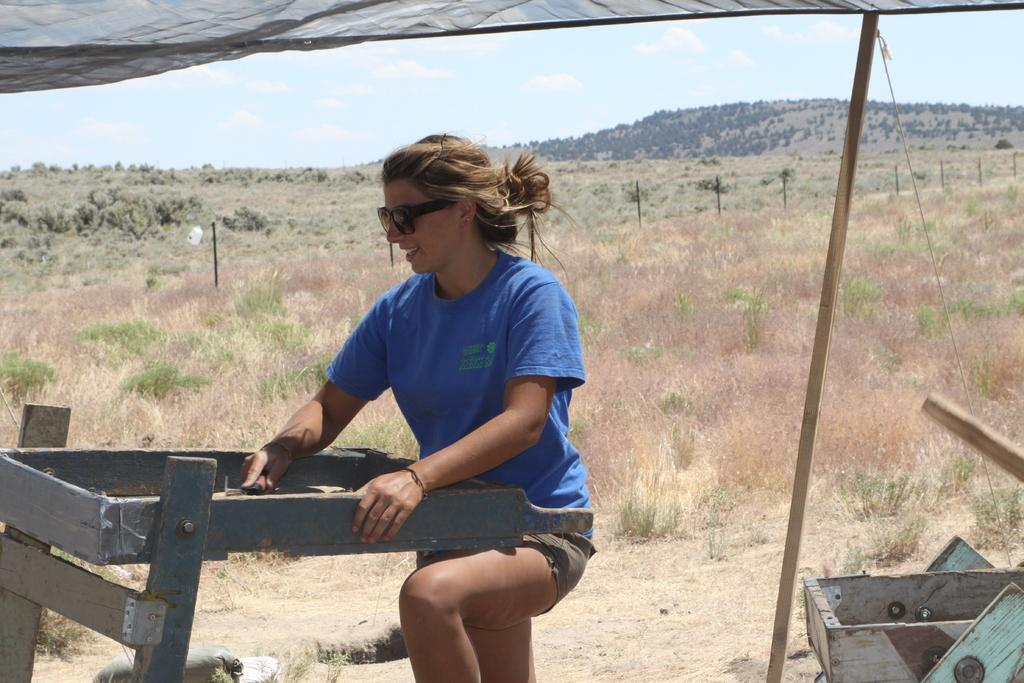What is the main subject of the image? There is a woman standing in the center of the image. Can you describe the woman's appearance? The woman is wearing spectacles. What can be seen in the background of the image? There are plants, grass, fencing, a hill, trees, and the sky visible in the background of the image. What is the condition of the sky in the image? Clouds are present in the sky. What is the rate at which the woman is playing chess in the image? There is no chess game or rate of play mentioned in the image; it only features a woman standing in the center and the background elements. 